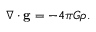Convert formula to latex. <formula><loc_0><loc_0><loc_500><loc_500>\nabla \cdot g = - 4 \pi G \rho .</formula> 